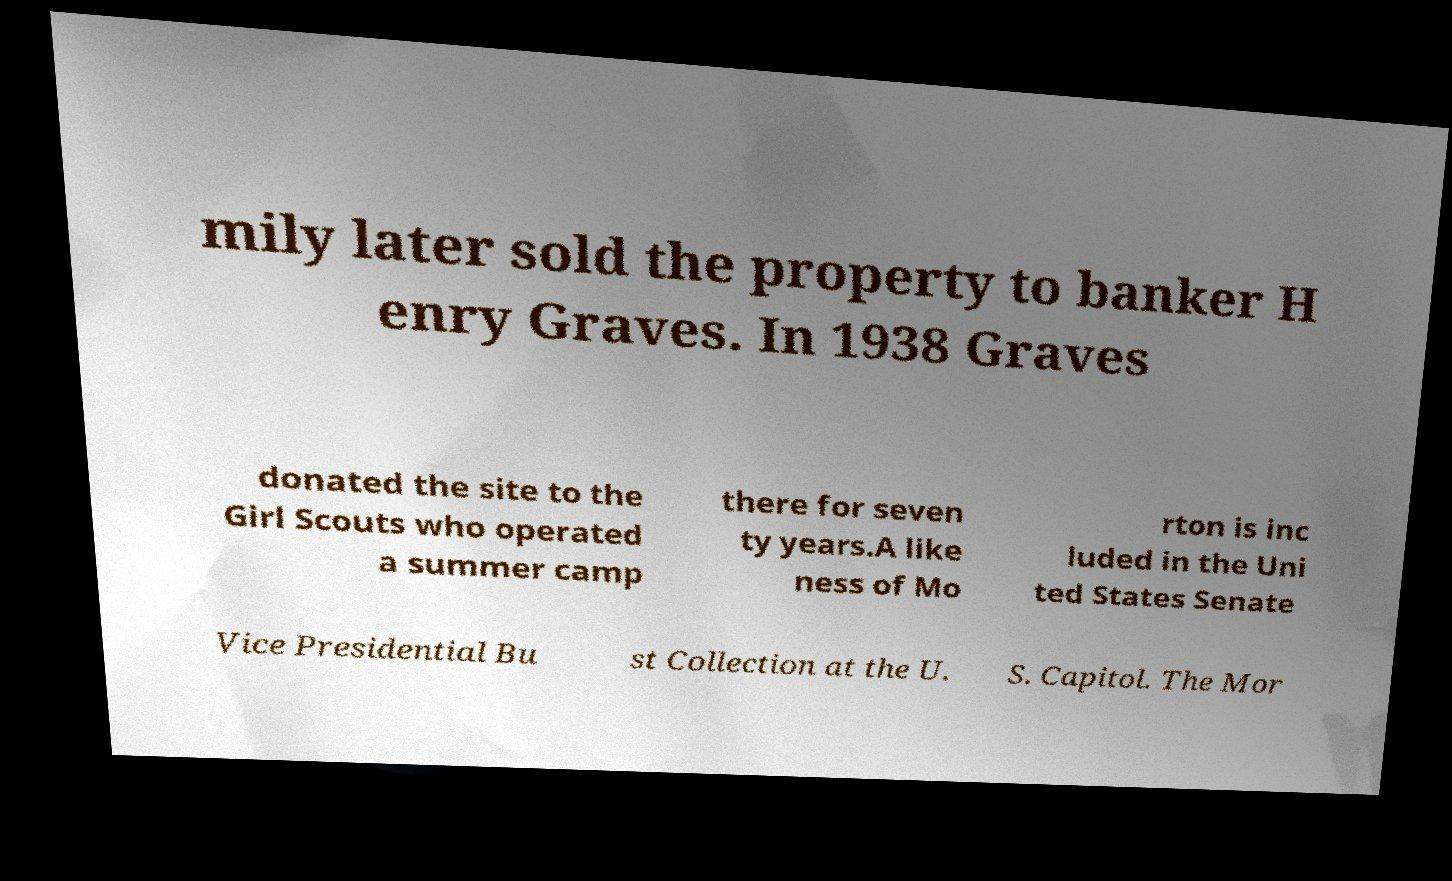For documentation purposes, I need the text within this image transcribed. Could you provide that? mily later sold the property to banker H enry Graves. In 1938 Graves donated the site to the Girl Scouts who operated a summer camp there for seven ty years.A like ness of Mo rton is inc luded in the Uni ted States Senate Vice Presidential Bu st Collection at the U. S. Capitol. The Mor 